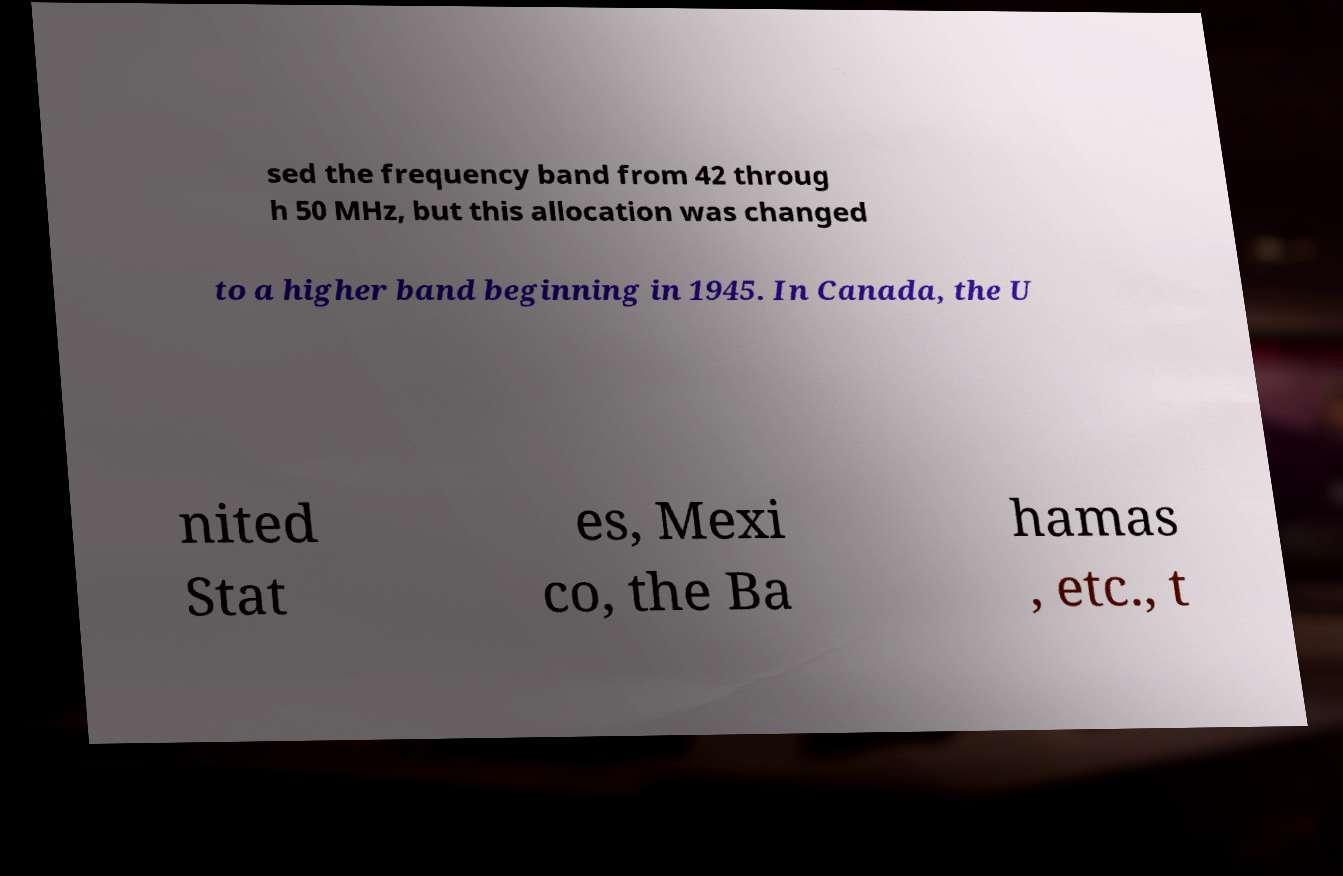Could you extract and type out the text from this image? sed the frequency band from 42 throug h 50 MHz, but this allocation was changed to a higher band beginning in 1945. In Canada, the U nited Stat es, Mexi co, the Ba hamas , etc., t 